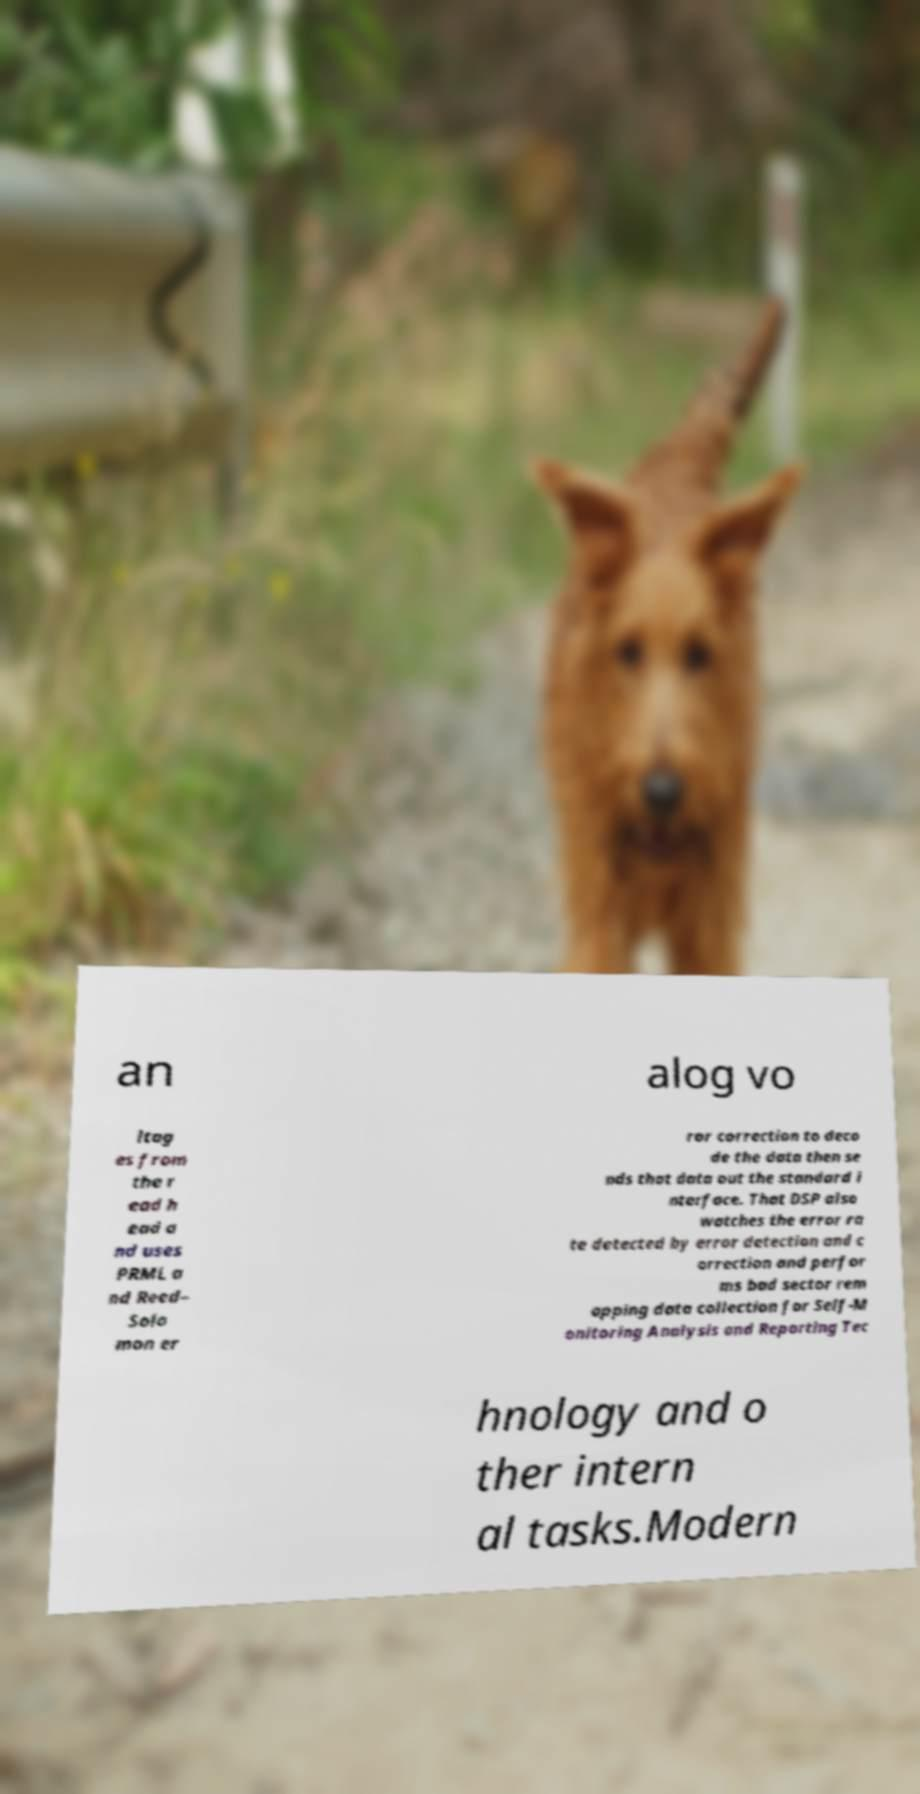Can you accurately transcribe the text from the provided image for me? an alog vo ltag es from the r ead h ead a nd uses PRML a nd Reed– Solo mon er ror correction to deco de the data then se nds that data out the standard i nterface. That DSP also watches the error ra te detected by error detection and c orrection and perfor ms bad sector rem apping data collection for Self-M onitoring Analysis and Reporting Tec hnology and o ther intern al tasks.Modern 